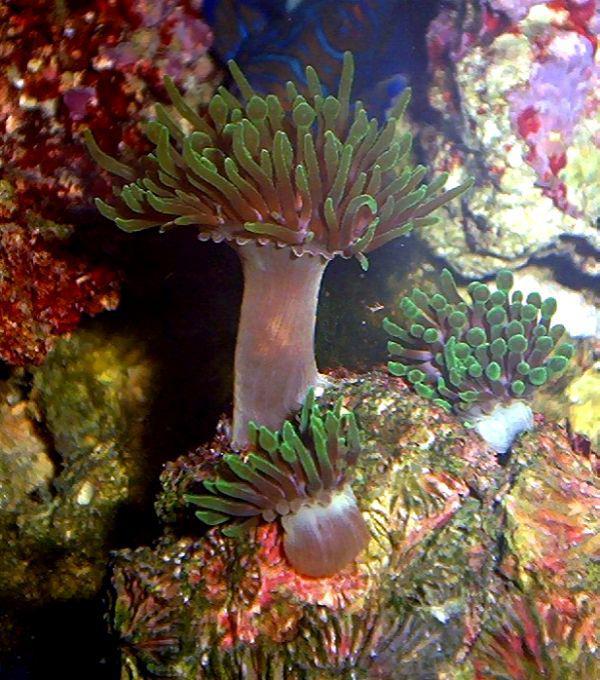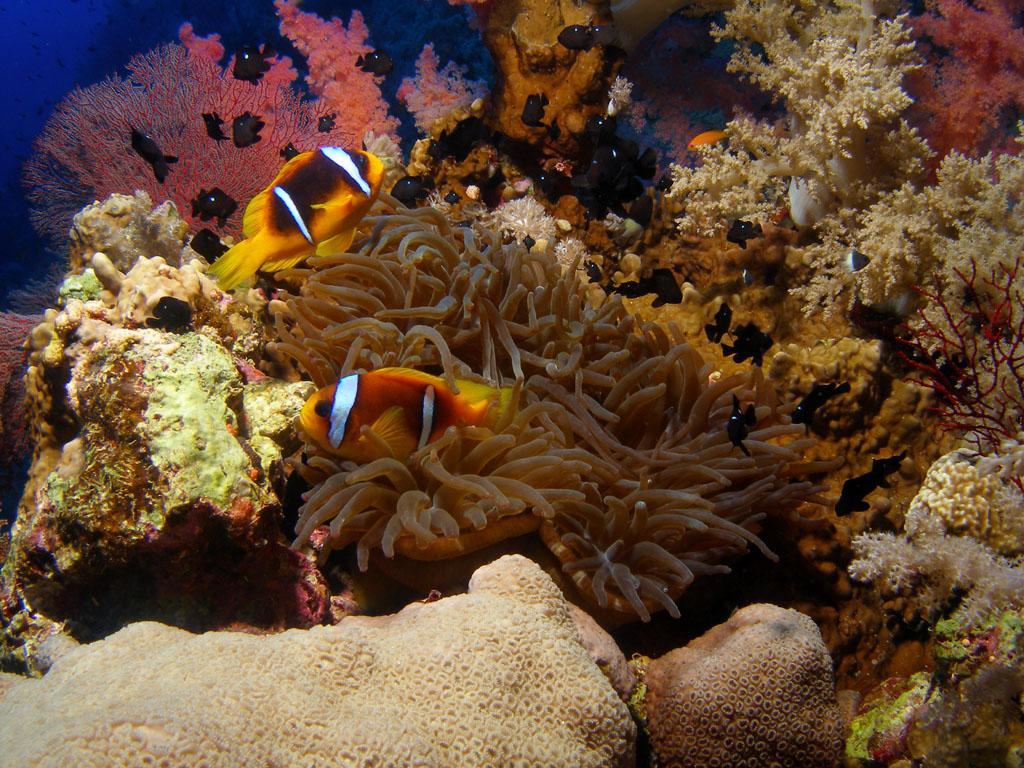The first image is the image on the left, the second image is the image on the right. Evaluate the accuracy of this statement regarding the images: "In at least one image there is a fish with two white stripes and a black belly swimming through a corral.". Is it true? Answer yes or no. Yes. 